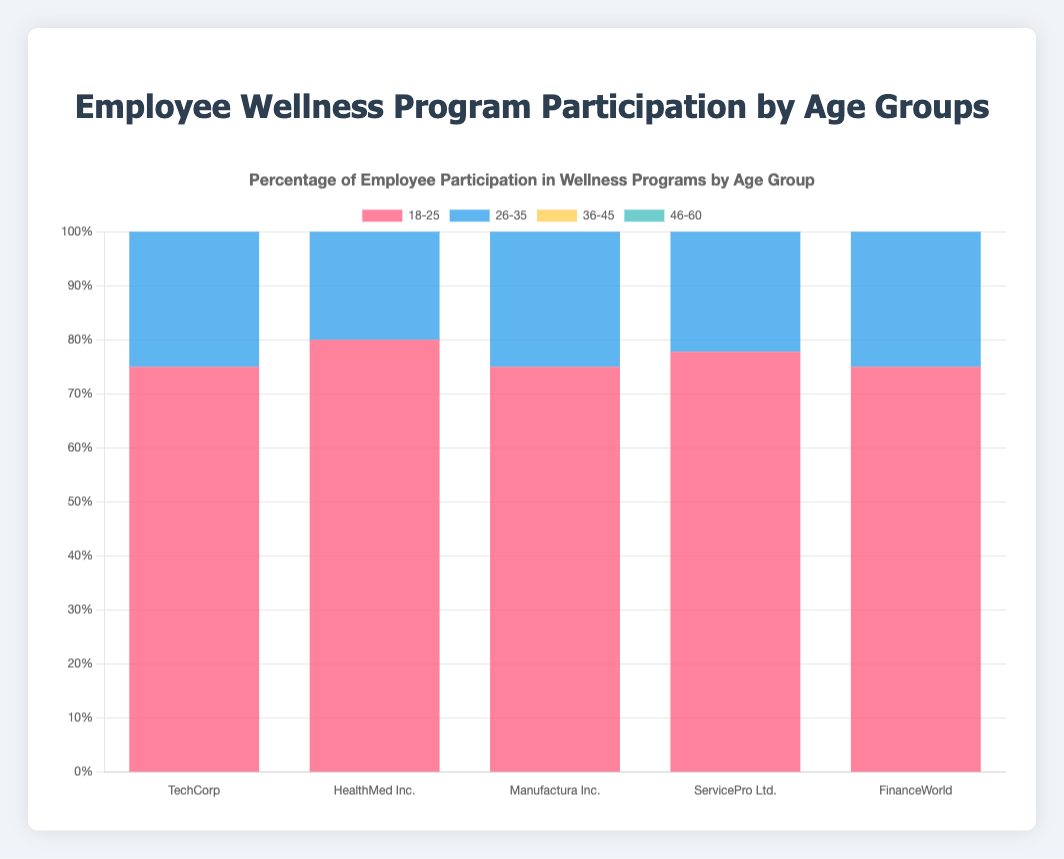Which company has the highest percentage of participation in the 18-25 age group? The 18-25 age group participation percentages across companies can be compared. TechCorp has 150/200 = 75%, HealthMed Inc. has 120/150 = 80%, Manufactura Inc. has 90/120 = 75%, ServicePro Ltd. has 70/90 = 77.8%, and FinanceWorld has 60/80 = 75%. Thus, HealthMed Inc. has the highest percentage.
Answer: HealthMed Inc Which age group at ServicePro Ltd. has the lowest participation percentage and what is it? By comparing the participation percentages for each age group at ServicePro Ltd., we find 18-25: 70/90 ≈ 77.8%, 26-35: 160/200 = 80%, 36-45: 110/140 ≈ 78.6%, and 46-60: 50/80 = 62.5%. Therefore, the 46-60 age group has the lowest percentage.
Answer: 46-60, 62.5% On average, which company has the highest participation percentage across all age groups? Calculate the average participation percentage for each company across the four age groups and find the highest. 
TechCorp: (75% + 83.3% + 79.5% + 53.3%) / 4 ≈ 72.8%
HealthMed Inc.: (80% + 80% + 76.2% + 70%) / 4 ≈ 76.6% 
Manufactura Inc.: (75% + 81.8% + 81.2% + 66.7%) / 4 ≈ 76.1%
ServicePro Ltd.: (77.8% + 80% + 78.6% + 62.5%) / 4 ≈ 74.7%
FinanceWorld: (75% + 77.8% + 76.9% + 57.1%) / 4 ≈ 71.7%
HealthMed Inc. has the highest average participation percentage.
Answer: HealthMed Inc., 76.6% Which company has the smallest difference in participation percentages between the 18-25 and 46-60 age groups? Calculate the difference in participation percentages for each company. TechCorp: 75% - 53.3% = 21.7%, HealthMed Inc.: 80% - 70% = 10%, Manufactura Inc.: 75% - 66.7% = 8.3%, ServicePro Ltd.: 77.8% - 62.5% = 15.3%, FinanceWorld: 75% - 57.1% = 17.9%. Manufactura Inc. has the smallest difference.
Answer: Manufactura Inc How much higher is the participation percentage of the 26-35 age group in TechCorp compared to FinanceWorld? Calculate the percentage difference between the two companies for the 26-35 age group. TechCorp: 250/300 = 83.3%, FinanceWorld: 140/180 ≈ 77.8%. The difference is 83.3% - 77.8% = 5.5%.
Answer: 5.5% What is the total percentage of employees participating in wellness programs at FinanceWorld? Sum the percentage of participants across all age groups at FinanceWorld: 
18-25: 75% (60/80)
26-35: 77.8% (140/180)
36-45: 76.9% (100/130)
46-60: 57.1% (40/70)
The total percentage is 75% + 77.8% + 76.9% + 57.1% = 286.8%.
Answer: 286.8% In which age group is TechCorp's highest participation percentage found? Compare the participation percentages of each age group in TechCorp: 18-25: 75%, 26-35: 83.3%, 36-45: 79.5%, 46-60: 53.3%. The highest percentage is found in the 26-35 age group.
Answer: 26-35 What percentage of ServicePro Ltd. employees in the 36-45 age group do not participate in the program? Calculate the percentage of non-participants for the 36-45 age group in ServicePro Ltd. Total employees: 140, Participants: 110. Non-participants: 140 - 110 = 30. The percentage is (30/140) * 100 ≈ 21.4%.
Answer: 21.4% 